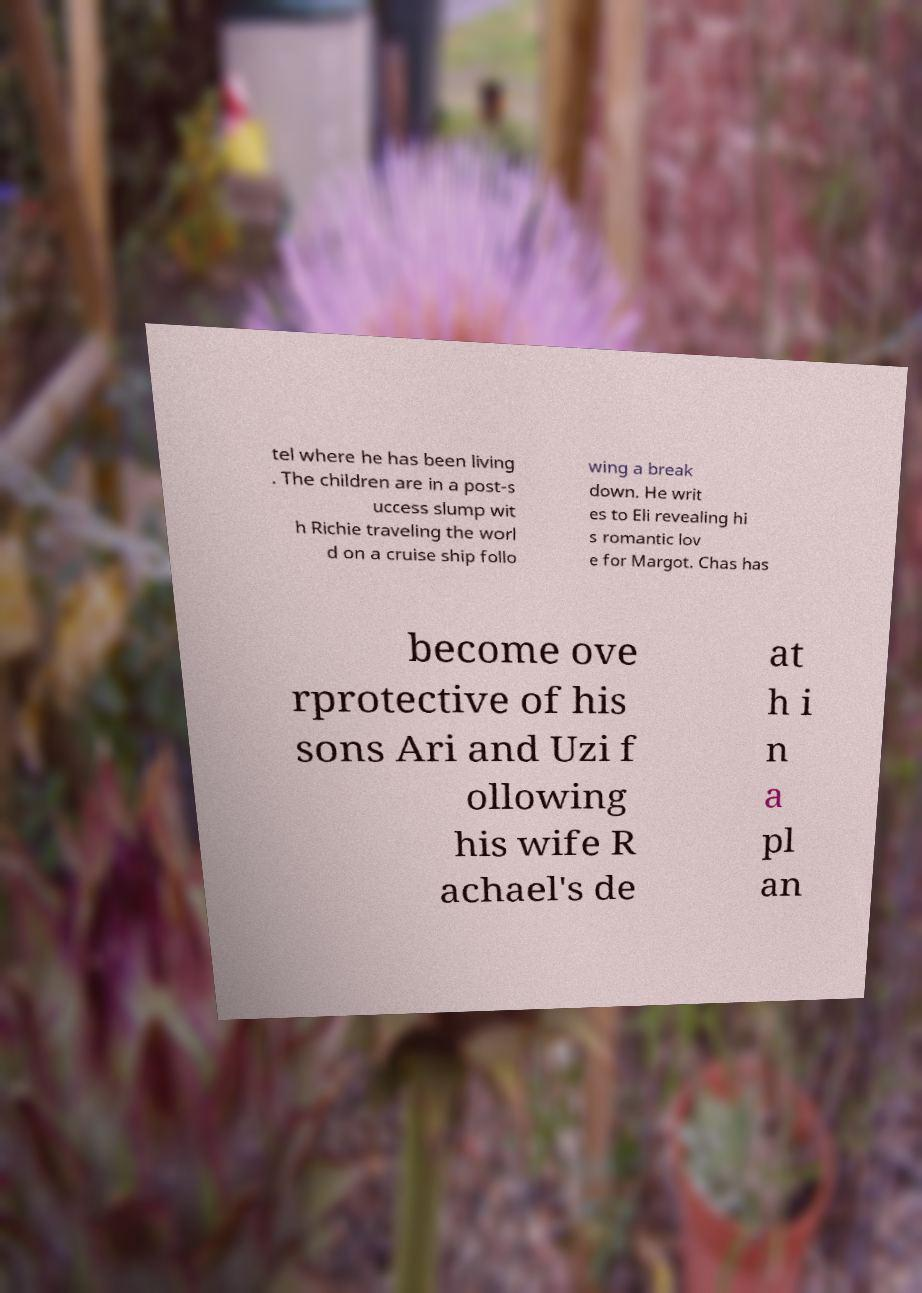What messages or text are displayed in this image? I need them in a readable, typed format. tel where he has been living . The children are in a post-s uccess slump wit h Richie traveling the worl d on a cruise ship follo wing a break down. He writ es to Eli revealing hi s romantic lov e for Margot. Chas has become ove rprotective of his sons Ari and Uzi f ollowing his wife R achael's de at h i n a pl an 